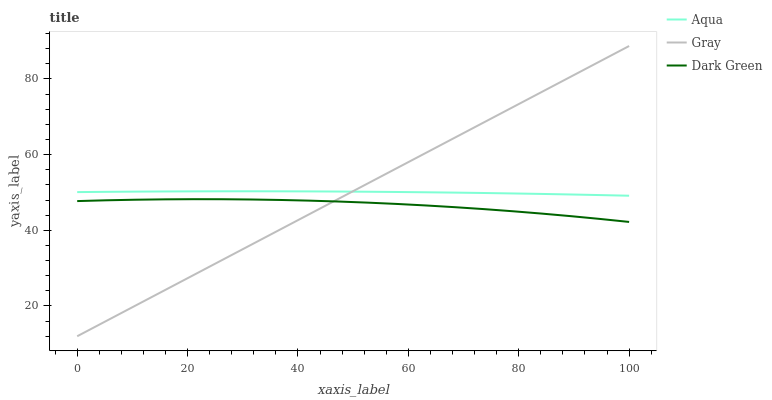Does Dark Green have the minimum area under the curve?
Answer yes or no. Yes. Does Gray have the maximum area under the curve?
Answer yes or no. Yes. Does Aqua have the minimum area under the curve?
Answer yes or no. No. Does Aqua have the maximum area under the curve?
Answer yes or no. No. Is Gray the smoothest?
Answer yes or no. Yes. Is Dark Green the roughest?
Answer yes or no. Yes. Is Aqua the smoothest?
Answer yes or no. No. Is Aqua the roughest?
Answer yes or no. No. Does Gray have the lowest value?
Answer yes or no. Yes. Does Dark Green have the lowest value?
Answer yes or no. No. Does Gray have the highest value?
Answer yes or no. Yes. Does Aqua have the highest value?
Answer yes or no. No. Is Dark Green less than Aqua?
Answer yes or no. Yes. Is Aqua greater than Dark Green?
Answer yes or no. Yes. Does Dark Green intersect Gray?
Answer yes or no. Yes. Is Dark Green less than Gray?
Answer yes or no. No. Is Dark Green greater than Gray?
Answer yes or no. No. Does Dark Green intersect Aqua?
Answer yes or no. No. 